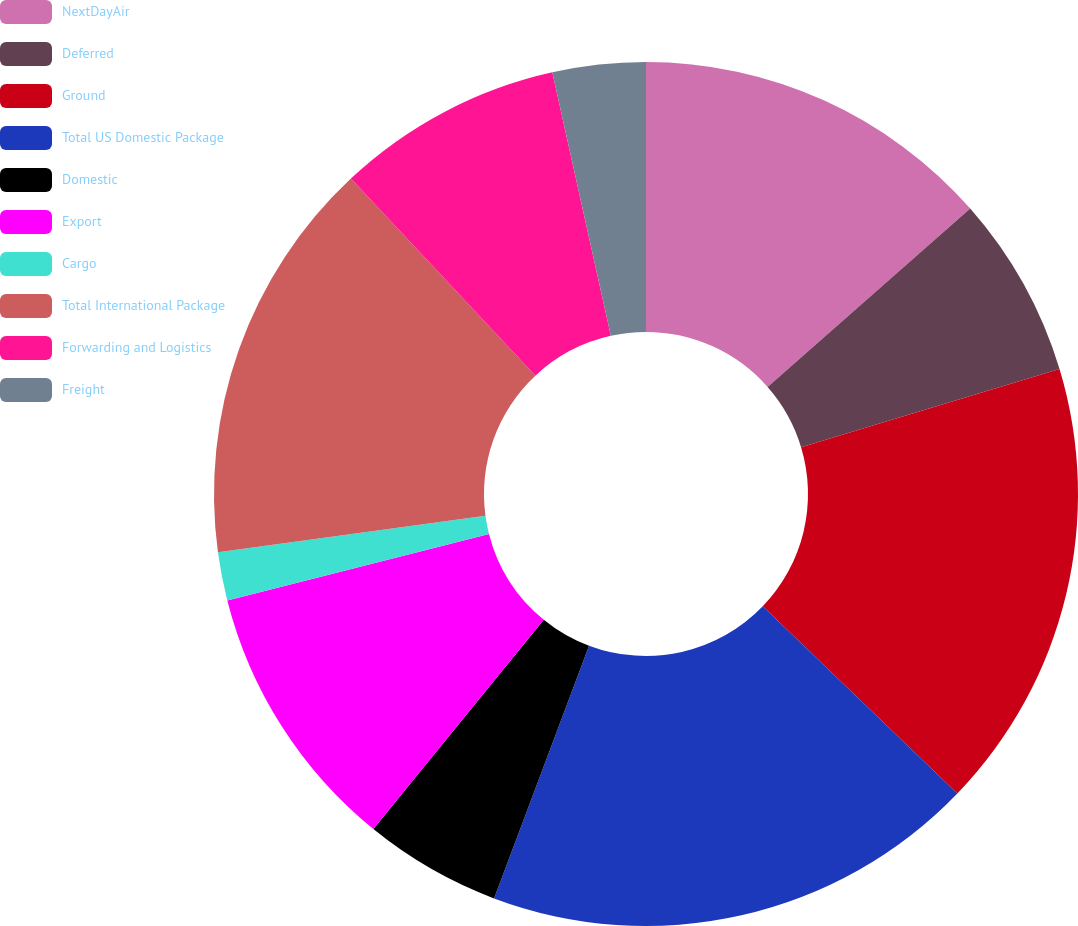<chart> <loc_0><loc_0><loc_500><loc_500><pie_chart><fcel>NextDayAir<fcel>Deferred<fcel>Ground<fcel>Total US Domestic Package<fcel>Domestic<fcel>Export<fcel>Cargo<fcel>Total International Package<fcel>Forwarding and Logistics<fcel>Freight<nl><fcel>13.51%<fcel>6.82%<fcel>16.86%<fcel>18.53%<fcel>5.15%<fcel>10.17%<fcel>1.81%<fcel>15.18%<fcel>8.49%<fcel>3.48%<nl></chart> 